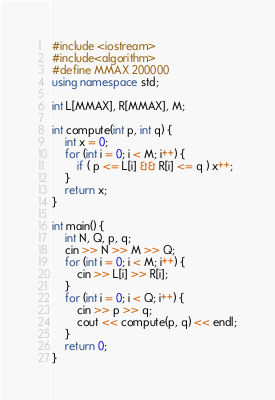<code> <loc_0><loc_0><loc_500><loc_500><_C++_>#include <iostream>
#include<algorithm>
#define MMAX 200000
using namespace std;

int L[MMAX], R[MMAX], M;

int compute(int p, int q) {
    int x = 0;
    for (int i = 0; i < M; i++) {
        if ( p <= L[i] && R[i] <= q ) x++;
    }
    return x;
}

int main() {
    int N, Q, p, q;
    cin >> N >> M >> Q;
    for (int i = 0; i < M; i++) {
        cin >> L[i] >> R[i];
    }
    for (int i = 0; i < Q; i++) {
        cin >> p >> q;
        cout << compute(p, q) << endl;
    }
    return 0;
}</code> 